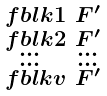Convert formula to latex. <formula><loc_0><loc_0><loc_500><loc_500>\begin{smallmatrix} \ f b l k { 1 } & F ^ { \prime } \\ \ f b l k { 2 } & F ^ { \prime } \\ \dots & \dots \\ \dots & \dots \\ \ f b l k { v } & F ^ { \prime } \end{smallmatrix}</formula> 